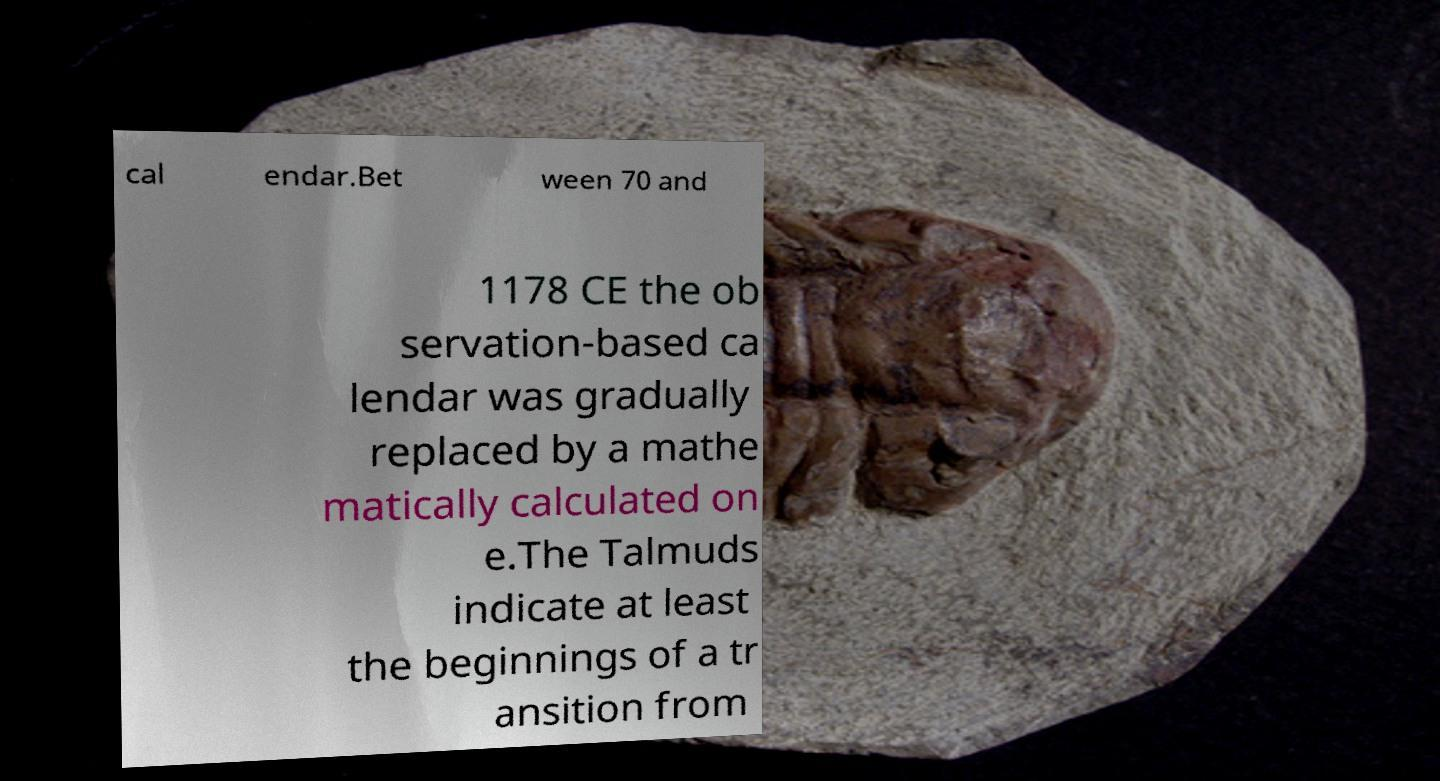I need the written content from this picture converted into text. Can you do that? cal endar.Bet ween 70 and 1178 CE the ob servation-based ca lendar was gradually replaced by a mathe matically calculated on e.The Talmuds indicate at least the beginnings of a tr ansition from 